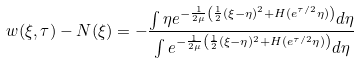Convert formula to latex. <formula><loc_0><loc_0><loc_500><loc_500>w ( \xi , \tau ) - N ( \xi ) = - \frac { \int \eta e ^ { - \frac { 1 } { 2 \mu } \left ( \frac { 1 } { 2 } ( \xi - \eta ) ^ { 2 } + H ( e ^ { \tau / 2 } \eta ) \right ) } d \eta } { \int e ^ { - \frac { 1 } { 2 \mu } \left ( \frac { 1 } { 2 } ( \xi - \eta ) ^ { 2 } + H ( e ^ { \tau / 2 } \eta ) \right ) } d \eta }</formula> 